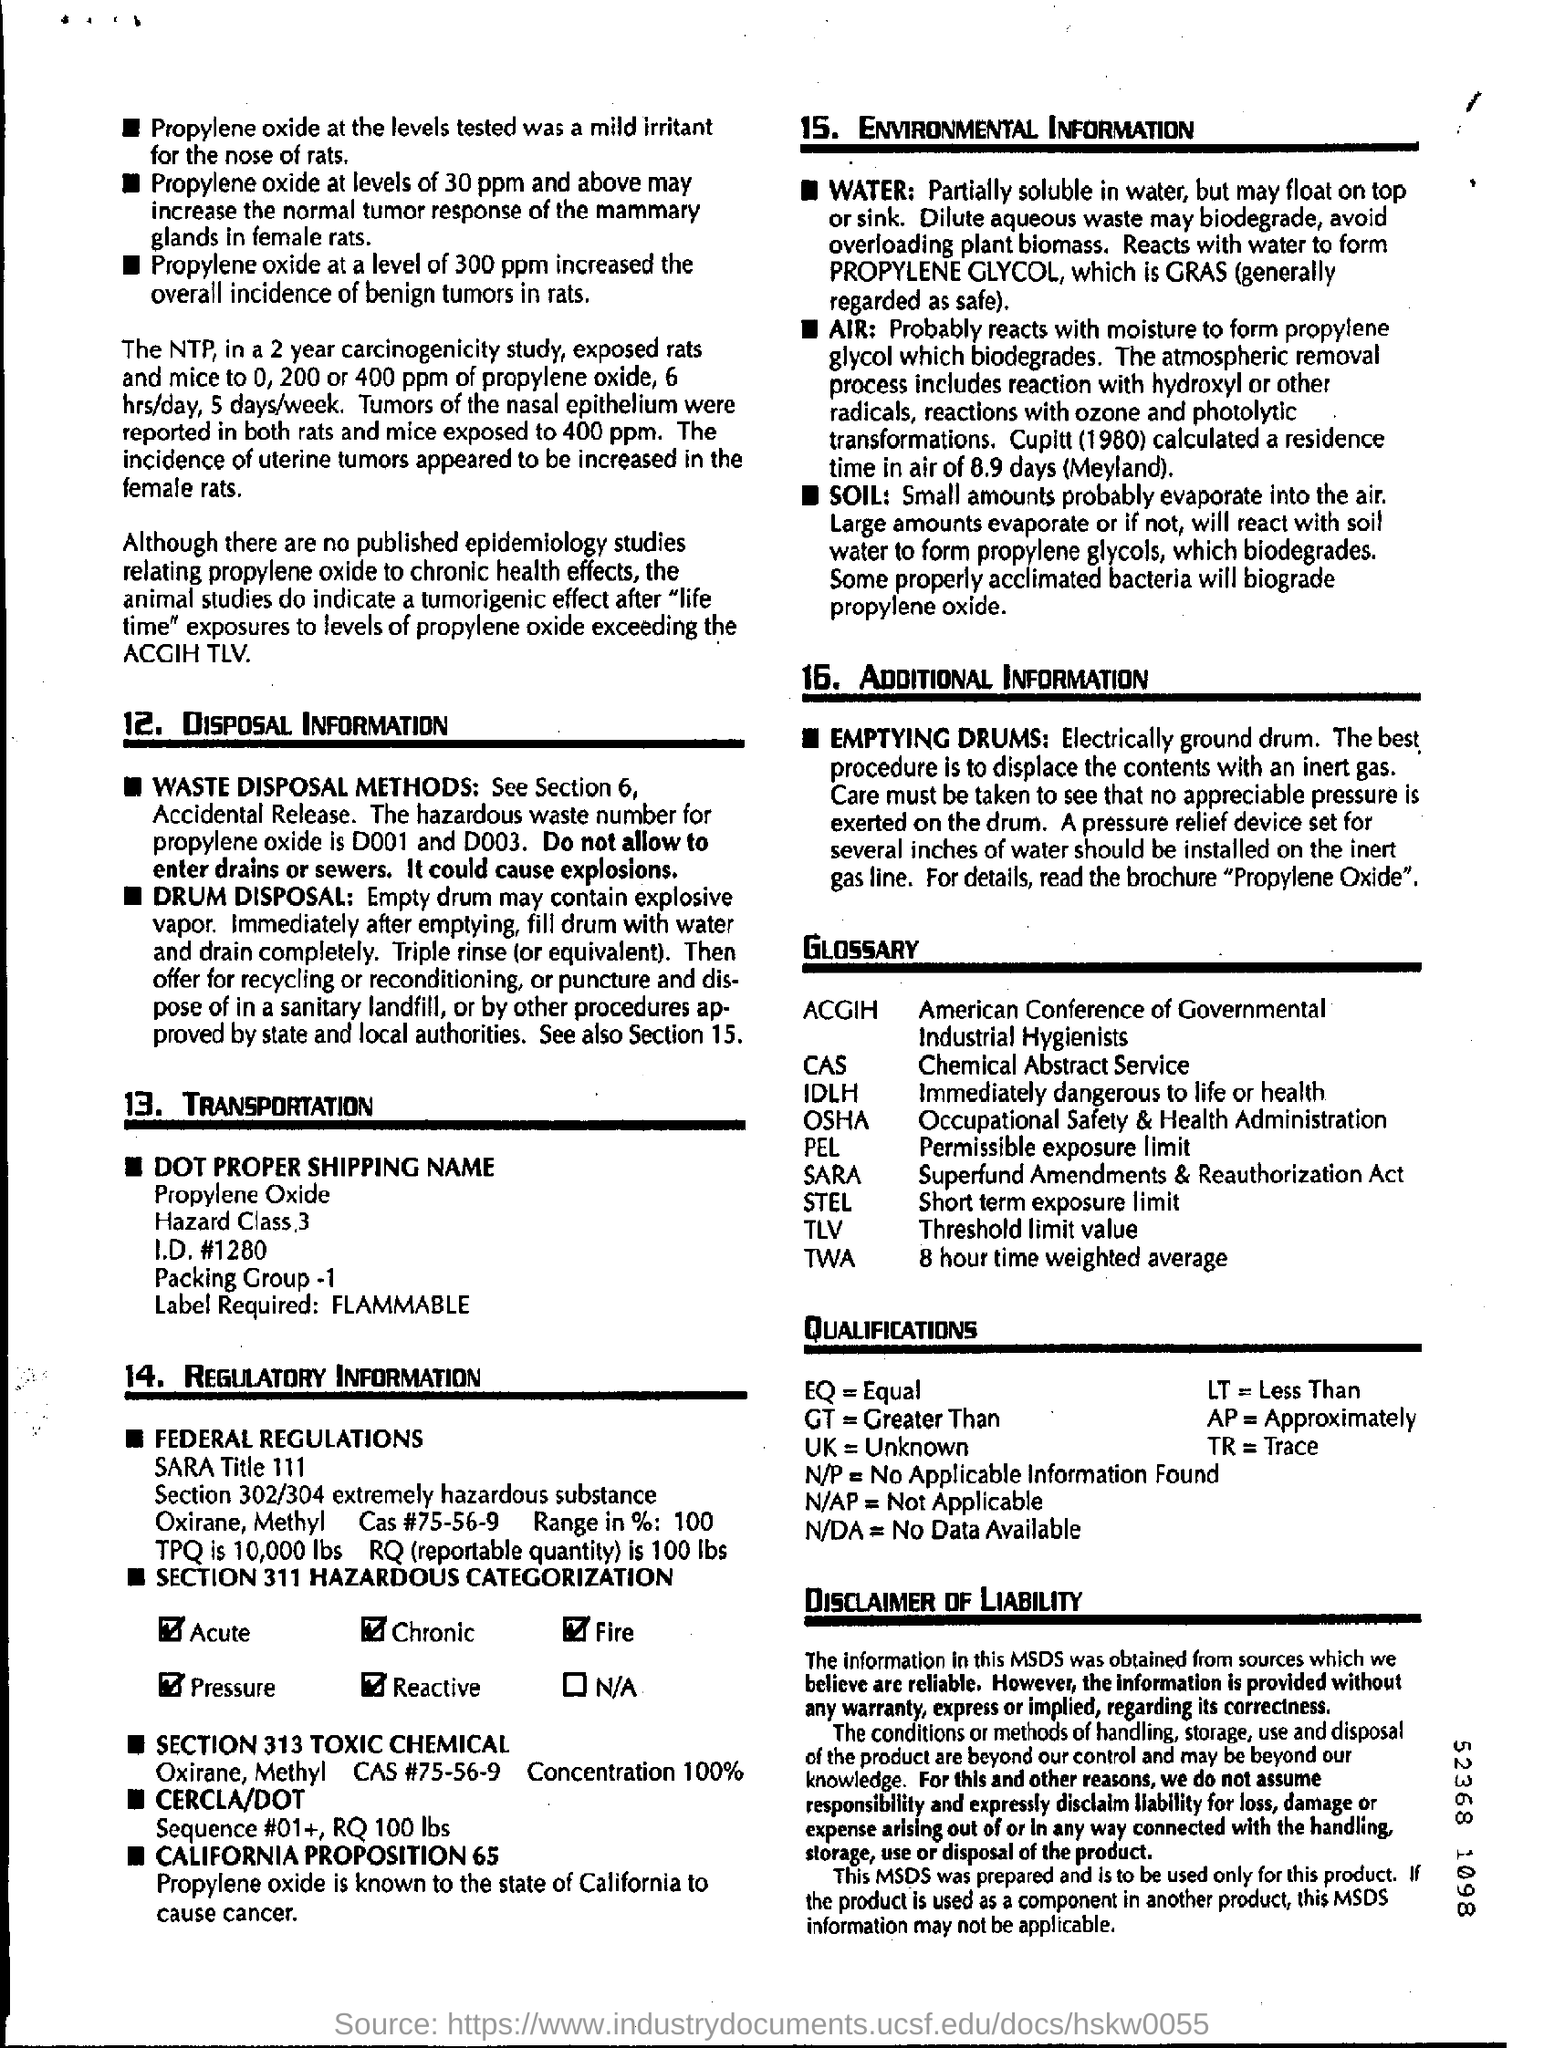At what level did propylene oxide increased the overall incidence of benign tumors in rats?
Make the answer very short. 300 ppm. What is the hazardous waste number for propylene oxide?
Offer a very short reply. D001 and D003. What forms after propylene oxide reacts with water?
Your response must be concise. GRAS. What does ACGIH stand for?
Your answer should be compact. American Conference of Governmental Industrial Hygienists. What does TLV denote?
Your answer should be very brief. Threshold limit value. 